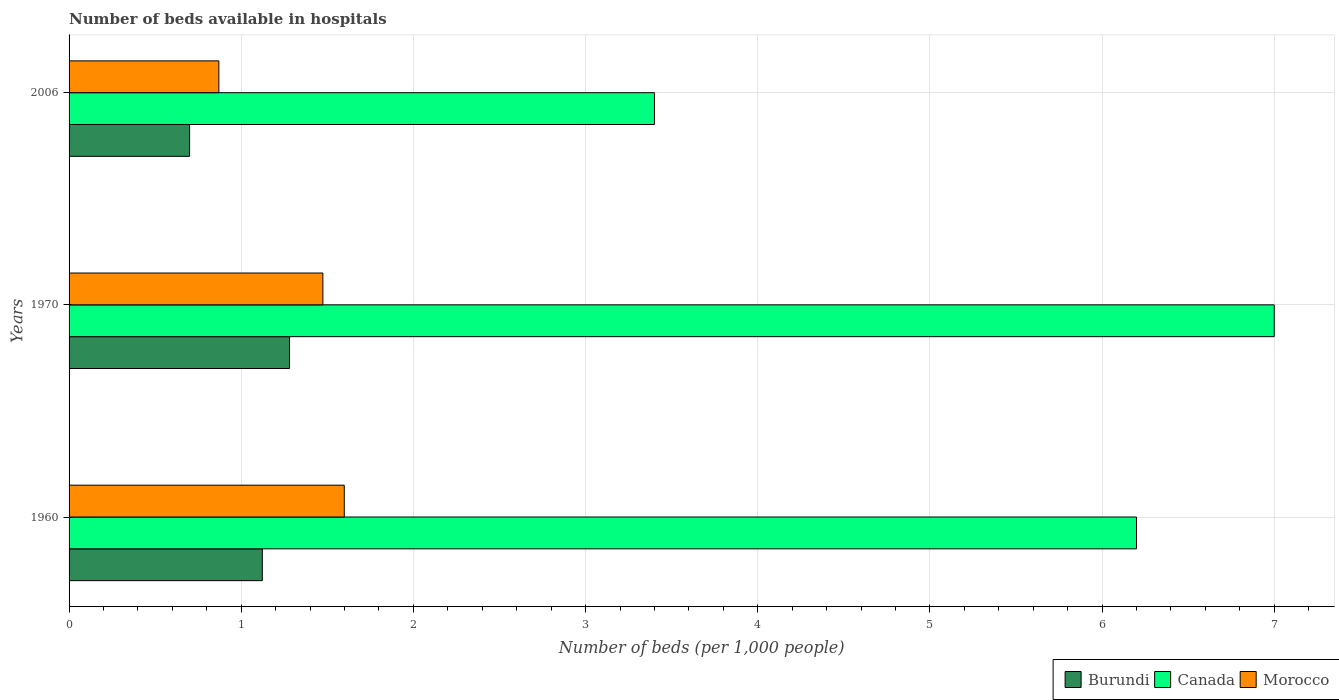How many different coloured bars are there?
Provide a short and direct response. 3. How many bars are there on the 3rd tick from the bottom?
Ensure brevity in your answer.  3. What is the label of the 3rd group of bars from the top?
Your answer should be compact. 1960. What is the number of beds in the hospiatls of in Morocco in 1970?
Ensure brevity in your answer.  1.47. Across all years, what is the maximum number of beds in the hospiatls of in Burundi?
Give a very brief answer. 1.28. Across all years, what is the minimum number of beds in the hospiatls of in Morocco?
Your response must be concise. 0.87. What is the total number of beds in the hospiatls of in Canada in the graph?
Provide a succinct answer. 16.6. What is the difference between the number of beds in the hospiatls of in Canada in 1960 and that in 1970?
Offer a terse response. -0.8. What is the difference between the number of beds in the hospiatls of in Morocco in 1970 and the number of beds in the hospiatls of in Burundi in 2006?
Ensure brevity in your answer.  0.77. What is the average number of beds in the hospiatls of in Morocco per year?
Offer a terse response. 1.31. In the year 1960, what is the difference between the number of beds in the hospiatls of in Morocco and number of beds in the hospiatls of in Burundi?
Ensure brevity in your answer.  0.48. What is the ratio of the number of beds in the hospiatls of in Morocco in 1970 to that in 2006?
Your answer should be compact. 1.69. Is the difference between the number of beds in the hospiatls of in Morocco in 1970 and 2006 greater than the difference between the number of beds in the hospiatls of in Burundi in 1970 and 2006?
Give a very brief answer. Yes. What is the difference between the highest and the second highest number of beds in the hospiatls of in Burundi?
Give a very brief answer. 0.16. What is the difference between the highest and the lowest number of beds in the hospiatls of in Canada?
Your answer should be very brief. 3.6. What does the 3rd bar from the bottom in 1970 represents?
Offer a very short reply. Morocco. Are all the bars in the graph horizontal?
Provide a short and direct response. Yes. Does the graph contain grids?
Give a very brief answer. Yes. Where does the legend appear in the graph?
Provide a short and direct response. Bottom right. How many legend labels are there?
Offer a very short reply. 3. What is the title of the graph?
Provide a succinct answer. Number of beds available in hospitals. What is the label or title of the X-axis?
Provide a succinct answer. Number of beds (per 1,0 people). What is the Number of beds (per 1,000 people) of Burundi in 1960?
Make the answer very short. 1.12. What is the Number of beds (per 1,000 people) in Canada in 1960?
Provide a succinct answer. 6.2. What is the Number of beds (per 1,000 people) of Morocco in 1960?
Make the answer very short. 1.6. What is the Number of beds (per 1,000 people) in Burundi in 1970?
Your answer should be very brief. 1.28. What is the Number of beds (per 1,000 people) in Canada in 1970?
Offer a terse response. 7. What is the Number of beds (per 1,000 people) of Morocco in 1970?
Your response must be concise. 1.47. What is the Number of beds (per 1,000 people) in Burundi in 2006?
Offer a terse response. 0.7. What is the Number of beds (per 1,000 people) of Canada in 2006?
Ensure brevity in your answer.  3.4. What is the Number of beds (per 1,000 people) in Morocco in 2006?
Provide a short and direct response. 0.87. Across all years, what is the maximum Number of beds (per 1,000 people) in Burundi?
Your response must be concise. 1.28. Across all years, what is the maximum Number of beds (per 1,000 people) of Canada?
Provide a short and direct response. 7. Across all years, what is the maximum Number of beds (per 1,000 people) of Morocco?
Offer a terse response. 1.6. Across all years, what is the minimum Number of beds (per 1,000 people) of Burundi?
Provide a succinct answer. 0.7. Across all years, what is the minimum Number of beds (per 1,000 people) of Canada?
Offer a very short reply. 3.4. Across all years, what is the minimum Number of beds (per 1,000 people) in Morocco?
Keep it short and to the point. 0.87. What is the total Number of beds (per 1,000 people) of Burundi in the graph?
Provide a short and direct response. 3.1. What is the total Number of beds (per 1,000 people) of Morocco in the graph?
Your answer should be compact. 3.94. What is the difference between the Number of beds (per 1,000 people) of Burundi in 1960 and that in 1970?
Make the answer very short. -0.16. What is the difference between the Number of beds (per 1,000 people) in Morocco in 1960 and that in 1970?
Your response must be concise. 0.12. What is the difference between the Number of beds (per 1,000 people) in Burundi in 1960 and that in 2006?
Keep it short and to the point. 0.42. What is the difference between the Number of beds (per 1,000 people) of Morocco in 1960 and that in 2006?
Your response must be concise. 0.73. What is the difference between the Number of beds (per 1,000 people) of Burundi in 1970 and that in 2006?
Keep it short and to the point. 0.58. What is the difference between the Number of beds (per 1,000 people) of Morocco in 1970 and that in 2006?
Offer a terse response. 0.6. What is the difference between the Number of beds (per 1,000 people) of Burundi in 1960 and the Number of beds (per 1,000 people) of Canada in 1970?
Ensure brevity in your answer.  -5.88. What is the difference between the Number of beds (per 1,000 people) in Burundi in 1960 and the Number of beds (per 1,000 people) in Morocco in 1970?
Make the answer very short. -0.35. What is the difference between the Number of beds (per 1,000 people) in Canada in 1960 and the Number of beds (per 1,000 people) in Morocco in 1970?
Provide a short and direct response. 4.73. What is the difference between the Number of beds (per 1,000 people) of Burundi in 1960 and the Number of beds (per 1,000 people) of Canada in 2006?
Keep it short and to the point. -2.28. What is the difference between the Number of beds (per 1,000 people) of Burundi in 1960 and the Number of beds (per 1,000 people) of Morocco in 2006?
Provide a succinct answer. 0.25. What is the difference between the Number of beds (per 1,000 people) in Canada in 1960 and the Number of beds (per 1,000 people) in Morocco in 2006?
Offer a very short reply. 5.33. What is the difference between the Number of beds (per 1,000 people) in Burundi in 1970 and the Number of beds (per 1,000 people) in Canada in 2006?
Your answer should be very brief. -2.12. What is the difference between the Number of beds (per 1,000 people) in Burundi in 1970 and the Number of beds (per 1,000 people) in Morocco in 2006?
Keep it short and to the point. 0.41. What is the difference between the Number of beds (per 1,000 people) of Canada in 1970 and the Number of beds (per 1,000 people) of Morocco in 2006?
Your answer should be compact. 6.13. What is the average Number of beds (per 1,000 people) in Burundi per year?
Offer a very short reply. 1.03. What is the average Number of beds (per 1,000 people) of Canada per year?
Ensure brevity in your answer.  5.53. What is the average Number of beds (per 1,000 people) of Morocco per year?
Your response must be concise. 1.31. In the year 1960, what is the difference between the Number of beds (per 1,000 people) in Burundi and Number of beds (per 1,000 people) in Canada?
Offer a terse response. -5.08. In the year 1960, what is the difference between the Number of beds (per 1,000 people) in Burundi and Number of beds (per 1,000 people) in Morocco?
Provide a short and direct response. -0.48. In the year 1960, what is the difference between the Number of beds (per 1,000 people) in Canada and Number of beds (per 1,000 people) in Morocco?
Your answer should be compact. 4.6. In the year 1970, what is the difference between the Number of beds (per 1,000 people) in Burundi and Number of beds (per 1,000 people) in Canada?
Ensure brevity in your answer.  -5.72. In the year 1970, what is the difference between the Number of beds (per 1,000 people) of Burundi and Number of beds (per 1,000 people) of Morocco?
Offer a terse response. -0.19. In the year 1970, what is the difference between the Number of beds (per 1,000 people) in Canada and Number of beds (per 1,000 people) in Morocco?
Your response must be concise. 5.53. In the year 2006, what is the difference between the Number of beds (per 1,000 people) of Burundi and Number of beds (per 1,000 people) of Canada?
Your answer should be very brief. -2.7. In the year 2006, what is the difference between the Number of beds (per 1,000 people) of Burundi and Number of beds (per 1,000 people) of Morocco?
Your answer should be compact. -0.17. In the year 2006, what is the difference between the Number of beds (per 1,000 people) in Canada and Number of beds (per 1,000 people) in Morocco?
Your answer should be very brief. 2.53. What is the ratio of the Number of beds (per 1,000 people) of Burundi in 1960 to that in 1970?
Offer a very short reply. 0.88. What is the ratio of the Number of beds (per 1,000 people) in Canada in 1960 to that in 1970?
Offer a very short reply. 0.89. What is the ratio of the Number of beds (per 1,000 people) in Morocco in 1960 to that in 1970?
Provide a succinct answer. 1.08. What is the ratio of the Number of beds (per 1,000 people) in Burundi in 1960 to that in 2006?
Your response must be concise. 1.6. What is the ratio of the Number of beds (per 1,000 people) of Canada in 1960 to that in 2006?
Offer a terse response. 1.82. What is the ratio of the Number of beds (per 1,000 people) of Morocco in 1960 to that in 2006?
Provide a short and direct response. 1.84. What is the ratio of the Number of beds (per 1,000 people) of Burundi in 1970 to that in 2006?
Provide a succinct answer. 1.83. What is the ratio of the Number of beds (per 1,000 people) in Canada in 1970 to that in 2006?
Keep it short and to the point. 2.06. What is the ratio of the Number of beds (per 1,000 people) of Morocco in 1970 to that in 2006?
Your response must be concise. 1.69. What is the difference between the highest and the second highest Number of beds (per 1,000 people) of Burundi?
Offer a very short reply. 0.16. What is the difference between the highest and the second highest Number of beds (per 1,000 people) in Morocco?
Offer a terse response. 0.12. What is the difference between the highest and the lowest Number of beds (per 1,000 people) in Burundi?
Give a very brief answer. 0.58. What is the difference between the highest and the lowest Number of beds (per 1,000 people) in Canada?
Make the answer very short. 3.6. What is the difference between the highest and the lowest Number of beds (per 1,000 people) in Morocco?
Make the answer very short. 0.73. 